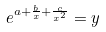<formula> <loc_0><loc_0><loc_500><loc_500>e ^ { a + \frac { b } { x } + \frac { c } { x ^ { 2 } } } = y</formula> 